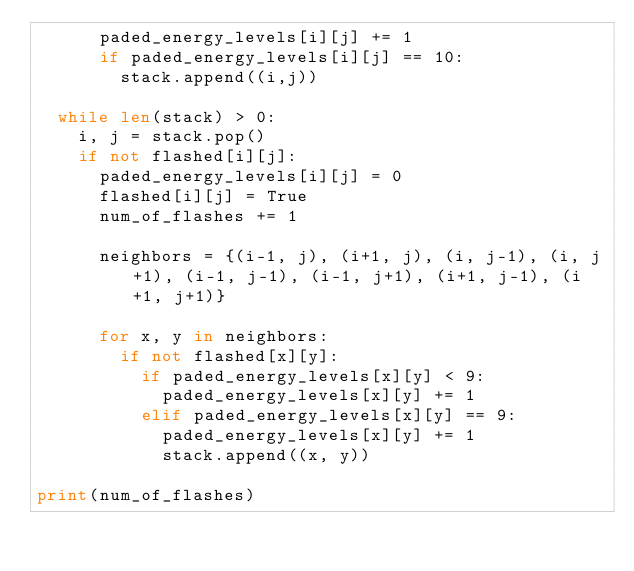Convert code to text. <code><loc_0><loc_0><loc_500><loc_500><_Python_>      paded_energy_levels[i][j] += 1
      if paded_energy_levels[i][j] == 10: 
        stack.append((i,j))

  while len(stack) > 0:
    i, j = stack.pop()
    if not flashed[i][j]:
      paded_energy_levels[i][j] = 0
      flashed[i][j] = True
      num_of_flashes += 1

      neighbors = {(i-1, j), (i+1, j), (i, j-1), (i, j+1), (i-1, j-1), (i-1, j+1), (i+1, j-1), (i+1, j+1)}

      for x, y in neighbors:
        if not flashed[x][y]:
          if paded_energy_levels[x][y] < 9:
            paded_energy_levels[x][y] += 1
          elif paded_energy_levels[x][y] == 9:
            paded_energy_levels[x][y] += 1
            stack.append((x, y))

print(num_of_flashes)</code> 